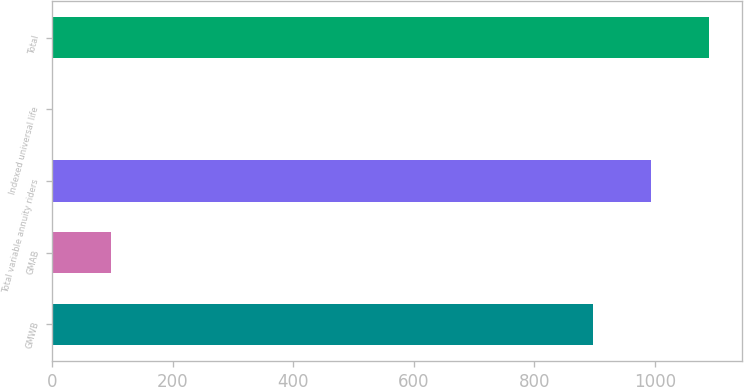<chart> <loc_0><loc_0><loc_500><loc_500><bar_chart><fcel>GMWB<fcel>GMAB<fcel>Total variable annuity riders<fcel>Indexed universal life<fcel>Total<nl><fcel>898<fcel>96.7<fcel>993.7<fcel>1<fcel>1089.4<nl></chart> 